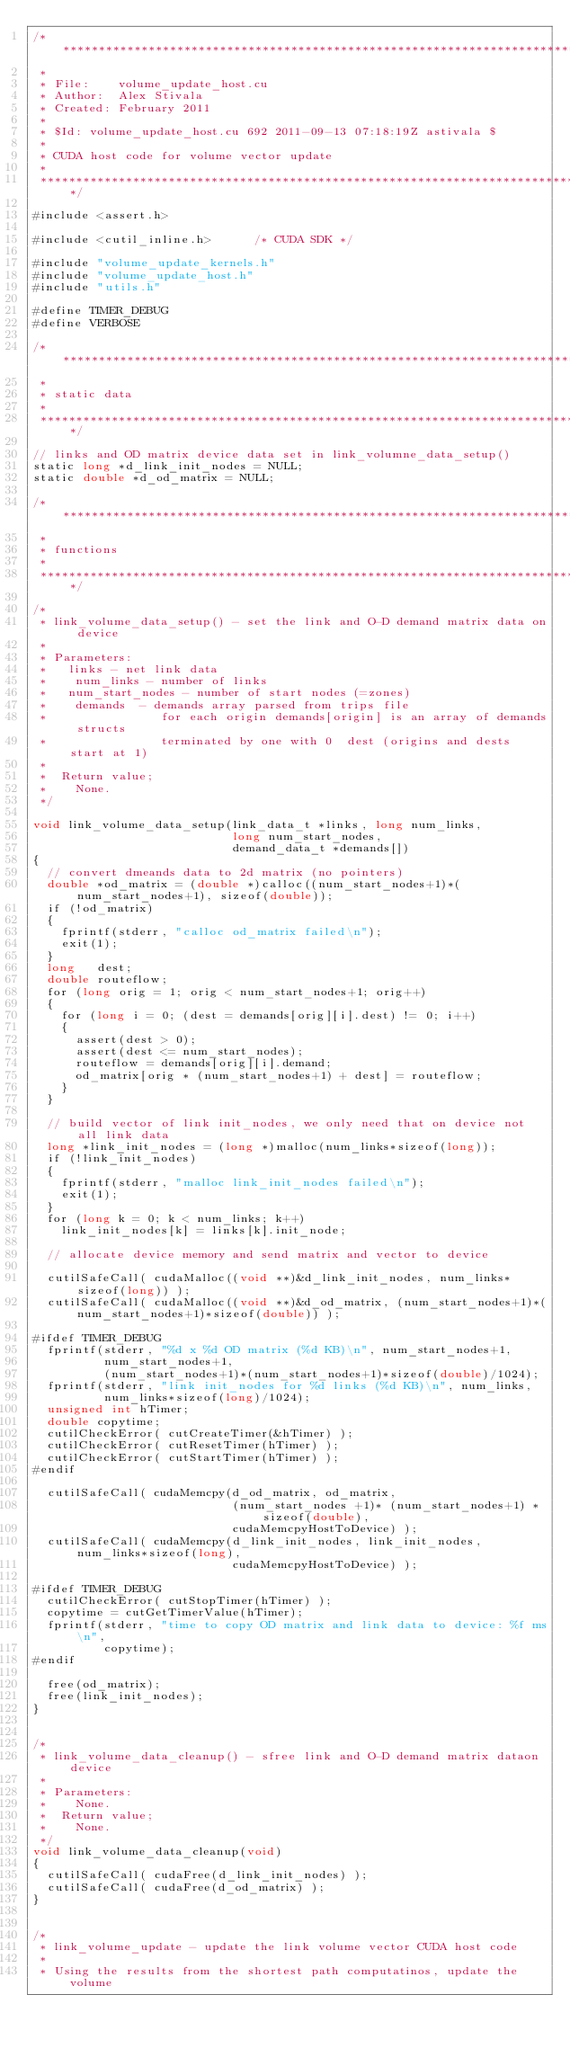<code> <loc_0><loc_0><loc_500><loc_500><_Cuda_>/*****************************************************************************
 * 
 * File:    volume_update_host.cu
 * Author:  Alex Stivala
 * Created: February 2011
 *
 * $Id: volume_update_host.cu 692 2011-09-13 07:18:19Z astivala $
 *
 * CUDA host code for volume vector update
 *
 ****************************************************************************/

#include <assert.h>

#include <cutil_inline.h>      /* CUDA SDK */

#include "volume_update_kernels.h"
#include "volume_update_host.h"
#include "utils.h"

#define TIMER_DEBUG
#define VERBOSE

/*****************************************************************************
 * 
 * static data
 *
 ****************************************************************************/

// links and OD matrix device data set in link_volumne_data_setup()
static long *d_link_init_nodes = NULL;
static double *d_od_matrix = NULL;

/*****************************************************************************
 * 
 * functions
 *
 ****************************************************************************/

/*
 * link_volume_data_setup() - set the link and O-D demand matrix data on device
 *
 * Parameters:
 *   links - net link data 
 *    num_links - number of links
 *   num_start_nodes - number of start nodes (=zones)
 *    demands  - demands array parsed from trips file
 *                for each origin demands[origin] is an array of demands structs
 *                terminated by one with 0  dest (origins and dests start at 1)
 *
 *  Return value;
 *    None.
 */

void link_volume_data_setup(link_data_t *links, long num_links,
                            long num_start_nodes,
                            demand_data_t *demands[])
{
  // convert dmeands data to 2d matrix (no pointers)
  double *od_matrix = (double *)calloc((num_start_nodes+1)*(num_start_nodes+1), sizeof(double));
  if (!od_matrix)
  {
    fprintf(stderr, "calloc od_matrix failed\n");
    exit(1);
  }
  long   dest;
  double routeflow;
  for (long orig = 1; orig < num_start_nodes+1; orig++)
  {
    for (long i = 0; (dest = demands[orig][i].dest) != 0; i++)
    {
      assert(dest > 0);
      assert(dest <= num_start_nodes);
      routeflow = demands[orig][i].demand;
      od_matrix[orig * (num_start_nodes+1) + dest] = routeflow;
    }
  }

  // build vector of link init_nodes, we only need that on device not all link data
  long *link_init_nodes = (long *)malloc(num_links*sizeof(long));
  if (!link_init_nodes) 
  {
    fprintf(stderr, "malloc link_init_nodes failed\n");
    exit(1);
  }
  for (long k = 0; k < num_links; k++)
    link_init_nodes[k] = links[k].init_node;

  // allocate device memory and send matrix and vector to device

  cutilSafeCall( cudaMalloc((void **)&d_link_init_nodes, num_links*sizeof(long)) );
  cutilSafeCall( cudaMalloc((void **)&d_od_matrix, (num_start_nodes+1)*(num_start_nodes+1)*sizeof(double)) );

#ifdef TIMER_DEBUG
  fprintf(stderr, "%d x %d OD matrix (%d KB)\n", num_start_nodes+1, 
          num_start_nodes+1,
          (num_start_nodes+1)*(num_start_nodes+1)*sizeof(double)/1024);
  fprintf(stderr, "link init_nodes for %d links (%d KB)\n", num_links,
          num_links*sizeof(long)/1024);
  unsigned int hTimer;
  double copytime;
  cutilCheckError( cutCreateTimer(&hTimer) );
  cutilCheckError( cutResetTimer(hTimer) );
  cutilCheckError( cutStartTimer(hTimer) );
#endif

  cutilSafeCall( cudaMemcpy(d_od_matrix, od_matrix, 
                            (num_start_nodes +1)* (num_start_nodes+1) * sizeof(double),
                            cudaMemcpyHostToDevice) );
  cutilSafeCall( cudaMemcpy(d_link_init_nodes, link_init_nodes, num_links*sizeof(long),
                            cudaMemcpyHostToDevice) );

#ifdef TIMER_DEBUG
  cutilCheckError( cutStopTimer(hTimer) );
  copytime = cutGetTimerValue(hTimer);
  fprintf(stderr, "time to copy OD matrix and link data to device: %f ms\n", 
          copytime);
#endif                            
  
  free(od_matrix);
  free(link_init_nodes);
}


/*
 * link_volume_data_cleanup() - sfree link and O-D demand matrix dataon device
 *
 * Parameters:
 *    None.
 *  Return value;
 *    None.
 */
void link_volume_data_cleanup(void)
{
  cutilSafeCall( cudaFree(d_link_init_nodes) );
  cutilSafeCall( cudaFree(d_od_matrix) );
}


/*
 * link_volume_update - update the link volume vector CUDA host code
 *
 * Using the results from the shortest path computatinos, update the volume</code> 